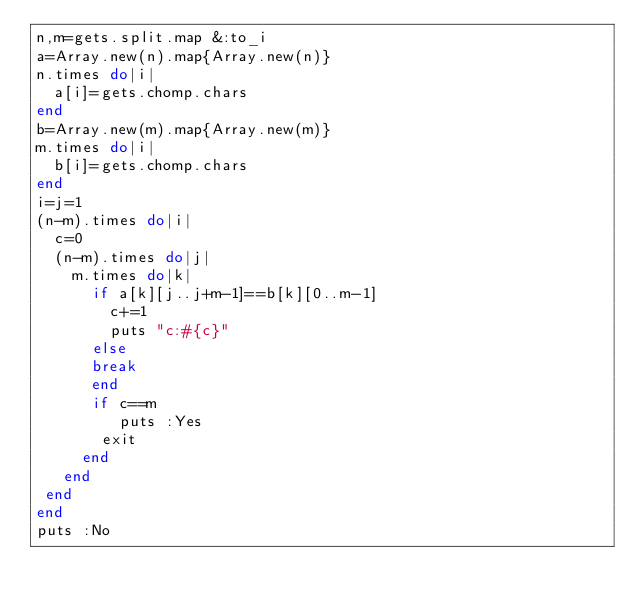<code> <loc_0><loc_0><loc_500><loc_500><_Ruby_>n,m=gets.split.map &:to_i
a=Array.new(n).map{Array.new(n)}
n.times do|i|
  a[i]=gets.chomp.chars
end
b=Array.new(m).map{Array.new(m)}
m.times do|i|
  b[i]=gets.chomp.chars
end
i=j=1
(n-m).times do|i|
  c=0
  (n-m).times do|j|
    m.times do|k|
      if a[k][j..j+m-1]==b[k][0..m-1]
        c+=1
        puts "c:#{c}"
      else
      break
      end
      if c==m
         puts :Yes
       exit
     end
   end
 end
end
puts :No
</code> 